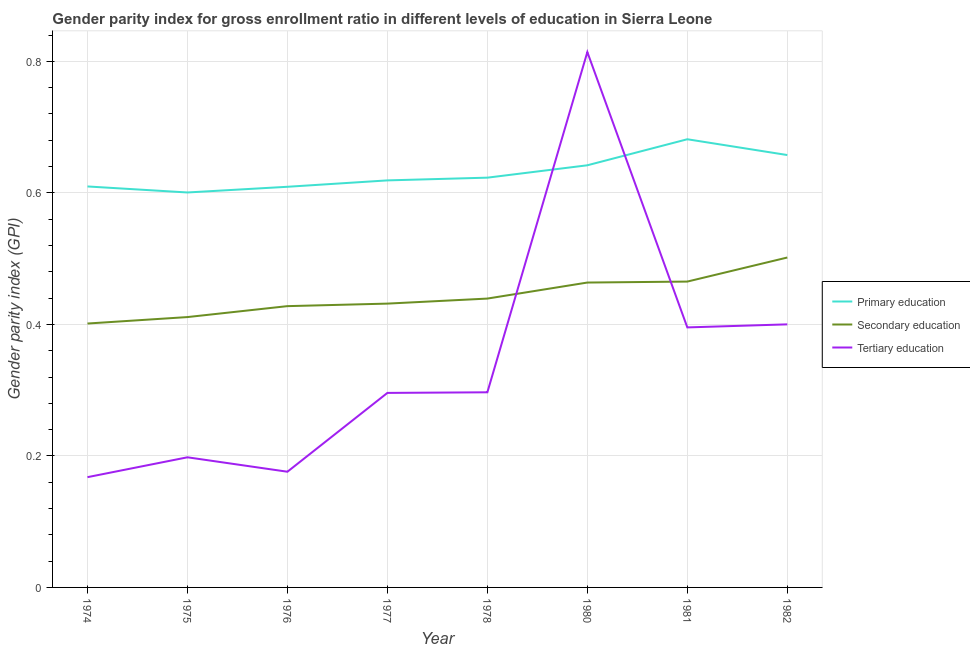Is the number of lines equal to the number of legend labels?
Make the answer very short. Yes. What is the gender parity index in primary education in 1974?
Offer a terse response. 0.61. Across all years, what is the maximum gender parity index in primary education?
Your answer should be compact. 0.68. Across all years, what is the minimum gender parity index in primary education?
Your answer should be very brief. 0.6. In which year was the gender parity index in primary education maximum?
Your answer should be very brief. 1981. In which year was the gender parity index in tertiary education minimum?
Provide a succinct answer. 1974. What is the total gender parity index in tertiary education in the graph?
Your answer should be very brief. 2.74. What is the difference between the gender parity index in primary education in 1974 and that in 1981?
Offer a terse response. -0.07. What is the difference between the gender parity index in primary education in 1977 and the gender parity index in secondary education in 1974?
Ensure brevity in your answer.  0.22. What is the average gender parity index in secondary education per year?
Make the answer very short. 0.44. In the year 1981, what is the difference between the gender parity index in tertiary education and gender parity index in primary education?
Ensure brevity in your answer.  -0.29. In how many years, is the gender parity index in tertiary education greater than 0.08?
Keep it short and to the point. 8. What is the ratio of the gender parity index in secondary education in 1977 to that in 1982?
Keep it short and to the point. 0.86. Is the gender parity index in primary education in 1980 less than that in 1982?
Offer a terse response. Yes. What is the difference between the highest and the second highest gender parity index in tertiary education?
Your answer should be compact. 0.41. What is the difference between the highest and the lowest gender parity index in primary education?
Provide a short and direct response. 0.08. Is the sum of the gender parity index in secondary education in 1974 and 1978 greater than the maximum gender parity index in tertiary education across all years?
Ensure brevity in your answer.  Yes. Does the gender parity index in tertiary education monotonically increase over the years?
Ensure brevity in your answer.  No. Is the gender parity index in tertiary education strictly less than the gender parity index in secondary education over the years?
Offer a very short reply. No. What is the difference between two consecutive major ticks on the Y-axis?
Your answer should be compact. 0.2. Does the graph contain grids?
Make the answer very short. Yes. Where does the legend appear in the graph?
Keep it short and to the point. Center right. How are the legend labels stacked?
Keep it short and to the point. Vertical. What is the title of the graph?
Provide a short and direct response. Gender parity index for gross enrollment ratio in different levels of education in Sierra Leone. Does "Textiles and clothing" appear as one of the legend labels in the graph?
Offer a very short reply. No. What is the label or title of the X-axis?
Keep it short and to the point. Year. What is the label or title of the Y-axis?
Make the answer very short. Gender parity index (GPI). What is the Gender parity index (GPI) of Primary education in 1974?
Your answer should be very brief. 0.61. What is the Gender parity index (GPI) in Secondary education in 1974?
Your answer should be compact. 0.4. What is the Gender parity index (GPI) in Tertiary education in 1974?
Your response must be concise. 0.17. What is the Gender parity index (GPI) of Primary education in 1975?
Your response must be concise. 0.6. What is the Gender parity index (GPI) of Secondary education in 1975?
Ensure brevity in your answer.  0.41. What is the Gender parity index (GPI) in Tertiary education in 1975?
Offer a terse response. 0.2. What is the Gender parity index (GPI) in Primary education in 1976?
Offer a very short reply. 0.61. What is the Gender parity index (GPI) in Secondary education in 1976?
Your response must be concise. 0.43. What is the Gender parity index (GPI) in Tertiary education in 1976?
Offer a very short reply. 0.18. What is the Gender parity index (GPI) of Primary education in 1977?
Your answer should be very brief. 0.62. What is the Gender parity index (GPI) in Secondary education in 1977?
Keep it short and to the point. 0.43. What is the Gender parity index (GPI) of Tertiary education in 1977?
Offer a terse response. 0.3. What is the Gender parity index (GPI) of Primary education in 1978?
Provide a short and direct response. 0.62. What is the Gender parity index (GPI) of Secondary education in 1978?
Keep it short and to the point. 0.44. What is the Gender parity index (GPI) of Tertiary education in 1978?
Provide a succinct answer. 0.3. What is the Gender parity index (GPI) in Primary education in 1980?
Give a very brief answer. 0.64. What is the Gender parity index (GPI) in Secondary education in 1980?
Ensure brevity in your answer.  0.46. What is the Gender parity index (GPI) of Tertiary education in 1980?
Keep it short and to the point. 0.81. What is the Gender parity index (GPI) in Primary education in 1981?
Provide a short and direct response. 0.68. What is the Gender parity index (GPI) of Secondary education in 1981?
Keep it short and to the point. 0.47. What is the Gender parity index (GPI) of Tertiary education in 1981?
Ensure brevity in your answer.  0.4. What is the Gender parity index (GPI) of Primary education in 1982?
Your answer should be very brief. 0.66. What is the Gender parity index (GPI) of Secondary education in 1982?
Make the answer very short. 0.5. What is the Gender parity index (GPI) in Tertiary education in 1982?
Your answer should be very brief. 0.4. Across all years, what is the maximum Gender parity index (GPI) in Primary education?
Your answer should be compact. 0.68. Across all years, what is the maximum Gender parity index (GPI) in Secondary education?
Provide a succinct answer. 0.5. Across all years, what is the maximum Gender parity index (GPI) of Tertiary education?
Give a very brief answer. 0.81. Across all years, what is the minimum Gender parity index (GPI) of Primary education?
Keep it short and to the point. 0.6. Across all years, what is the minimum Gender parity index (GPI) in Secondary education?
Keep it short and to the point. 0.4. Across all years, what is the minimum Gender parity index (GPI) in Tertiary education?
Provide a succinct answer. 0.17. What is the total Gender parity index (GPI) of Primary education in the graph?
Offer a very short reply. 5.04. What is the total Gender parity index (GPI) of Secondary education in the graph?
Provide a short and direct response. 3.54. What is the total Gender parity index (GPI) of Tertiary education in the graph?
Your answer should be very brief. 2.74. What is the difference between the Gender parity index (GPI) of Primary education in 1974 and that in 1975?
Your response must be concise. 0.01. What is the difference between the Gender parity index (GPI) in Secondary education in 1974 and that in 1975?
Provide a short and direct response. -0.01. What is the difference between the Gender parity index (GPI) of Tertiary education in 1974 and that in 1975?
Provide a succinct answer. -0.03. What is the difference between the Gender parity index (GPI) of Secondary education in 1974 and that in 1976?
Offer a very short reply. -0.03. What is the difference between the Gender parity index (GPI) in Tertiary education in 1974 and that in 1976?
Ensure brevity in your answer.  -0.01. What is the difference between the Gender parity index (GPI) of Primary education in 1974 and that in 1977?
Your response must be concise. -0.01. What is the difference between the Gender parity index (GPI) in Secondary education in 1974 and that in 1977?
Offer a very short reply. -0.03. What is the difference between the Gender parity index (GPI) of Tertiary education in 1974 and that in 1977?
Ensure brevity in your answer.  -0.13. What is the difference between the Gender parity index (GPI) in Primary education in 1974 and that in 1978?
Provide a short and direct response. -0.01. What is the difference between the Gender parity index (GPI) in Secondary education in 1974 and that in 1978?
Provide a succinct answer. -0.04. What is the difference between the Gender parity index (GPI) in Tertiary education in 1974 and that in 1978?
Give a very brief answer. -0.13. What is the difference between the Gender parity index (GPI) of Primary education in 1974 and that in 1980?
Your answer should be very brief. -0.03. What is the difference between the Gender parity index (GPI) of Secondary education in 1974 and that in 1980?
Give a very brief answer. -0.06. What is the difference between the Gender parity index (GPI) in Tertiary education in 1974 and that in 1980?
Ensure brevity in your answer.  -0.65. What is the difference between the Gender parity index (GPI) in Primary education in 1974 and that in 1981?
Your answer should be very brief. -0.07. What is the difference between the Gender parity index (GPI) of Secondary education in 1974 and that in 1981?
Make the answer very short. -0.06. What is the difference between the Gender parity index (GPI) of Tertiary education in 1974 and that in 1981?
Give a very brief answer. -0.23. What is the difference between the Gender parity index (GPI) in Primary education in 1974 and that in 1982?
Keep it short and to the point. -0.05. What is the difference between the Gender parity index (GPI) in Secondary education in 1974 and that in 1982?
Keep it short and to the point. -0.1. What is the difference between the Gender parity index (GPI) in Tertiary education in 1974 and that in 1982?
Your answer should be compact. -0.23. What is the difference between the Gender parity index (GPI) in Primary education in 1975 and that in 1976?
Your answer should be very brief. -0.01. What is the difference between the Gender parity index (GPI) of Secondary education in 1975 and that in 1976?
Your answer should be compact. -0.02. What is the difference between the Gender parity index (GPI) of Tertiary education in 1975 and that in 1976?
Your answer should be compact. 0.02. What is the difference between the Gender parity index (GPI) in Primary education in 1975 and that in 1977?
Provide a short and direct response. -0.02. What is the difference between the Gender parity index (GPI) in Secondary education in 1975 and that in 1977?
Offer a terse response. -0.02. What is the difference between the Gender parity index (GPI) in Tertiary education in 1975 and that in 1977?
Give a very brief answer. -0.1. What is the difference between the Gender parity index (GPI) in Primary education in 1975 and that in 1978?
Your answer should be very brief. -0.02. What is the difference between the Gender parity index (GPI) in Secondary education in 1975 and that in 1978?
Offer a very short reply. -0.03. What is the difference between the Gender parity index (GPI) in Tertiary education in 1975 and that in 1978?
Keep it short and to the point. -0.1. What is the difference between the Gender parity index (GPI) in Primary education in 1975 and that in 1980?
Your answer should be very brief. -0.04. What is the difference between the Gender parity index (GPI) of Secondary education in 1975 and that in 1980?
Offer a very short reply. -0.05. What is the difference between the Gender parity index (GPI) of Tertiary education in 1975 and that in 1980?
Provide a succinct answer. -0.62. What is the difference between the Gender parity index (GPI) in Primary education in 1975 and that in 1981?
Offer a very short reply. -0.08. What is the difference between the Gender parity index (GPI) of Secondary education in 1975 and that in 1981?
Offer a terse response. -0.05. What is the difference between the Gender parity index (GPI) of Tertiary education in 1975 and that in 1981?
Give a very brief answer. -0.2. What is the difference between the Gender parity index (GPI) of Primary education in 1975 and that in 1982?
Offer a very short reply. -0.06. What is the difference between the Gender parity index (GPI) of Secondary education in 1975 and that in 1982?
Ensure brevity in your answer.  -0.09. What is the difference between the Gender parity index (GPI) in Tertiary education in 1975 and that in 1982?
Keep it short and to the point. -0.2. What is the difference between the Gender parity index (GPI) of Primary education in 1976 and that in 1977?
Your answer should be very brief. -0.01. What is the difference between the Gender parity index (GPI) of Secondary education in 1976 and that in 1977?
Your response must be concise. -0. What is the difference between the Gender parity index (GPI) of Tertiary education in 1976 and that in 1977?
Your answer should be very brief. -0.12. What is the difference between the Gender parity index (GPI) of Primary education in 1976 and that in 1978?
Offer a terse response. -0.01. What is the difference between the Gender parity index (GPI) in Secondary education in 1976 and that in 1978?
Ensure brevity in your answer.  -0.01. What is the difference between the Gender parity index (GPI) of Tertiary education in 1976 and that in 1978?
Provide a short and direct response. -0.12. What is the difference between the Gender parity index (GPI) in Primary education in 1976 and that in 1980?
Offer a terse response. -0.03. What is the difference between the Gender parity index (GPI) of Secondary education in 1976 and that in 1980?
Offer a terse response. -0.04. What is the difference between the Gender parity index (GPI) of Tertiary education in 1976 and that in 1980?
Keep it short and to the point. -0.64. What is the difference between the Gender parity index (GPI) in Primary education in 1976 and that in 1981?
Keep it short and to the point. -0.07. What is the difference between the Gender parity index (GPI) in Secondary education in 1976 and that in 1981?
Your answer should be compact. -0.04. What is the difference between the Gender parity index (GPI) in Tertiary education in 1976 and that in 1981?
Keep it short and to the point. -0.22. What is the difference between the Gender parity index (GPI) in Primary education in 1976 and that in 1982?
Your response must be concise. -0.05. What is the difference between the Gender parity index (GPI) of Secondary education in 1976 and that in 1982?
Give a very brief answer. -0.07. What is the difference between the Gender parity index (GPI) of Tertiary education in 1976 and that in 1982?
Give a very brief answer. -0.22. What is the difference between the Gender parity index (GPI) of Primary education in 1977 and that in 1978?
Give a very brief answer. -0. What is the difference between the Gender parity index (GPI) in Secondary education in 1977 and that in 1978?
Give a very brief answer. -0.01. What is the difference between the Gender parity index (GPI) in Tertiary education in 1977 and that in 1978?
Keep it short and to the point. -0. What is the difference between the Gender parity index (GPI) in Primary education in 1977 and that in 1980?
Ensure brevity in your answer.  -0.02. What is the difference between the Gender parity index (GPI) of Secondary education in 1977 and that in 1980?
Give a very brief answer. -0.03. What is the difference between the Gender parity index (GPI) in Tertiary education in 1977 and that in 1980?
Make the answer very short. -0.52. What is the difference between the Gender parity index (GPI) in Primary education in 1977 and that in 1981?
Ensure brevity in your answer.  -0.06. What is the difference between the Gender parity index (GPI) in Secondary education in 1977 and that in 1981?
Provide a succinct answer. -0.03. What is the difference between the Gender parity index (GPI) of Tertiary education in 1977 and that in 1981?
Ensure brevity in your answer.  -0.1. What is the difference between the Gender parity index (GPI) in Primary education in 1977 and that in 1982?
Offer a terse response. -0.04. What is the difference between the Gender parity index (GPI) in Secondary education in 1977 and that in 1982?
Give a very brief answer. -0.07. What is the difference between the Gender parity index (GPI) of Tertiary education in 1977 and that in 1982?
Provide a short and direct response. -0.1. What is the difference between the Gender parity index (GPI) of Primary education in 1978 and that in 1980?
Your answer should be compact. -0.02. What is the difference between the Gender parity index (GPI) of Secondary education in 1978 and that in 1980?
Your response must be concise. -0.02. What is the difference between the Gender parity index (GPI) of Tertiary education in 1978 and that in 1980?
Keep it short and to the point. -0.52. What is the difference between the Gender parity index (GPI) of Primary education in 1978 and that in 1981?
Give a very brief answer. -0.06. What is the difference between the Gender parity index (GPI) of Secondary education in 1978 and that in 1981?
Give a very brief answer. -0.03. What is the difference between the Gender parity index (GPI) in Tertiary education in 1978 and that in 1981?
Provide a short and direct response. -0.1. What is the difference between the Gender parity index (GPI) of Primary education in 1978 and that in 1982?
Keep it short and to the point. -0.03. What is the difference between the Gender parity index (GPI) in Secondary education in 1978 and that in 1982?
Ensure brevity in your answer.  -0.06. What is the difference between the Gender parity index (GPI) of Tertiary education in 1978 and that in 1982?
Ensure brevity in your answer.  -0.1. What is the difference between the Gender parity index (GPI) in Primary education in 1980 and that in 1981?
Provide a short and direct response. -0.04. What is the difference between the Gender parity index (GPI) of Secondary education in 1980 and that in 1981?
Provide a short and direct response. -0. What is the difference between the Gender parity index (GPI) of Tertiary education in 1980 and that in 1981?
Keep it short and to the point. 0.42. What is the difference between the Gender parity index (GPI) in Primary education in 1980 and that in 1982?
Give a very brief answer. -0.02. What is the difference between the Gender parity index (GPI) in Secondary education in 1980 and that in 1982?
Offer a terse response. -0.04. What is the difference between the Gender parity index (GPI) in Tertiary education in 1980 and that in 1982?
Give a very brief answer. 0.41. What is the difference between the Gender parity index (GPI) of Primary education in 1981 and that in 1982?
Keep it short and to the point. 0.02. What is the difference between the Gender parity index (GPI) of Secondary education in 1981 and that in 1982?
Keep it short and to the point. -0.04. What is the difference between the Gender parity index (GPI) in Tertiary education in 1981 and that in 1982?
Your response must be concise. -0. What is the difference between the Gender parity index (GPI) of Primary education in 1974 and the Gender parity index (GPI) of Secondary education in 1975?
Your answer should be compact. 0.2. What is the difference between the Gender parity index (GPI) of Primary education in 1974 and the Gender parity index (GPI) of Tertiary education in 1975?
Ensure brevity in your answer.  0.41. What is the difference between the Gender parity index (GPI) of Secondary education in 1974 and the Gender parity index (GPI) of Tertiary education in 1975?
Offer a terse response. 0.2. What is the difference between the Gender parity index (GPI) in Primary education in 1974 and the Gender parity index (GPI) in Secondary education in 1976?
Keep it short and to the point. 0.18. What is the difference between the Gender parity index (GPI) of Primary education in 1974 and the Gender parity index (GPI) of Tertiary education in 1976?
Your response must be concise. 0.43. What is the difference between the Gender parity index (GPI) of Secondary education in 1974 and the Gender parity index (GPI) of Tertiary education in 1976?
Ensure brevity in your answer.  0.23. What is the difference between the Gender parity index (GPI) in Primary education in 1974 and the Gender parity index (GPI) in Secondary education in 1977?
Offer a very short reply. 0.18. What is the difference between the Gender parity index (GPI) in Primary education in 1974 and the Gender parity index (GPI) in Tertiary education in 1977?
Keep it short and to the point. 0.31. What is the difference between the Gender parity index (GPI) in Secondary education in 1974 and the Gender parity index (GPI) in Tertiary education in 1977?
Ensure brevity in your answer.  0.11. What is the difference between the Gender parity index (GPI) in Primary education in 1974 and the Gender parity index (GPI) in Secondary education in 1978?
Your answer should be compact. 0.17. What is the difference between the Gender parity index (GPI) of Primary education in 1974 and the Gender parity index (GPI) of Tertiary education in 1978?
Give a very brief answer. 0.31. What is the difference between the Gender parity index (GPI) of Secondary education in 1974 and the Gender parity index (GPI) of Tertiary education in 1978?
Give a very brief answer. 0.1. What is the difference between the Gender parity index (GPI) of Primary education in 1974 and the Gender parity index (GPI) of Secondary education in 1980?
Offer a very short reply. 0.15. What is the difference between the Gender parity index (GPI) of Primary education in 1974 and the Gender parity index (GPI) of Tertiary education in 1980?
Offer a very short reply. -0.2. What is the difference between the Gender parity index (GPI) in Secondary education in 1974 and the Gender parity index (GPI) in Tertiary education in 1980?
Provide a short and direct response. -0.41. What is the difference between the Gender parity index (GPI) in Primary education in 1974 and the Gender parity index (GPI) in Secondary education in 1981?
Your answer should be very brief. 0.14. What is the difference between the Gender parity index (GPI) of Primary education in 1974 and the Gender parity index (GPI) of Tertiary education in 1981?
Offer a terse response. 0.21. What is the difference between the Gender parity index (GPI) of Secondary education in 1974 and the Gender parity index (GPI) of Tertiary education in 1981?
Your answer should be compact. 0.01. What is the difference between the Gender parity index (GPI) in Primary education in 1974 and the Gender parity index (GPI) in Secondary education in 1982?
Provide a short and direct response. 0.11. What is the difference between the Gender parity index (GPI) of Primary education in 1974 and the Gender parity index (GPI) of Tertiary education in 1982?
Keep it short and to the point. 0.21. What is the difference between the Gender parity index (GPI) in Secondary education in 1974 and the Gender parity index (GPI) in Tertiary education in 1982?
Make the answer very short. 0. What is the difference between the Gender parity index (GPI) in Primary education in 1975 and the Gender parity index (GPI) in Secondary education in 1976?
Provide a succinct answer. 0.17. What is the difference between the Gender parity index (GPI) in Primary education in 1975 and the Gender parity index (GPI) in Tertiary education in 1976?
Provide a short and direct response. 0.42. What is the difference between the Gender parity index (GPI) in Secondary education in 1975 and the Gender parity index (GPI) in Tertiary education in 1976?
Your answer should be compact. 0.24. What is the difference between the Gender parity index (GPI) in Primary education in 1975 and the Gender parity index (GPI) in Secondary education in 1977?
Your response must be concise. 0.17. What is the difference between the Gender parity index (GPI) in Primary education in 1975 and the Gender parity index (GPI) in Tertiary education in 1977?
Keep it short and to the point. 0.3. What is the difference between the Gender parity index (GPI) of Secondary education in 1975 and the Gender parity index (GPI) of Tertiary education in 1977?
Provide a succinct answer. 0.12. What is the difference between the Gender parity index (GPI) in Primary education in 1975 and the Gender parity index (GPI) in Secondary education in 1978?
Offer a terse response. 0.16. What is the difference between the Gender parity index (GPI) of Primary education in 1975 and the Gender parity index (GPI) of Tertiary education in 1978?
Provide a short and direct response. 0.3. What is the difference between the Gender parity index (GPI) of Secondary education in 1975 and the Gender parity index (GPI) of Tertiary education in 1978?
Keep it short and to the point. 0.11. What is the difference between the Gender parity index (GPI) of Primary education in 1975 and the Gender parity index (GPI) of Secondary education in 1980?
Provide a succinct answer. 0.14. What is the difference between the Gender parity index (GPI) of Primary education in 1975 and the Gender parity index (GPI) of Tertiary education in 1980?
Provide a short and direct response. -0.21. What is the difference between the Gender parity index (GPI) in Secondary education in 1975 and the Gender parity index (GPI) in Tertiary education in 1980?
Keep it short and to the point. -0.4. What is the difference between the Gender parity index (GPI) in Primary education in 1975 and the Gender parity index (GPI) in Secondary education in 1981?
Provide a succinct answer. 0.14. What is the difference between the Gender parity index (GPI) in Primary education in 1975 and the Gender parity index (GPI) in Tertiary education in 1981?
Offer a very short reply. 0.21. What is the difference between the Gender parity index (GPI) in Secondary education in 1975 and the Gender parity index (GPI) in Tertiary education in 1981?
Keep it short and to the point. 0.02. What is the difference between the Gender parity index (GPI) in Primary education in 1975 and the Gender parity index (GPI) in Secondary education in 1982?
Offer a terse response. 0.1. What is the difference between the Gender parity index (GPI) in Primary education in 1975 and the Gender parity index (GPI) in Tertiary education in 1982?
Give a very brief answer. 0.2. What is the difference between the Gender parity index (GPI) of Secondary education in 1975 and the Gender parity index (GPI) of Tertiary education in 1982?
Your answer should be very brief. 0.01. What is the difference between the Gender parity index (GPI) in Primary education in 1976 and the Gender parity index (GPI) in Secondary education in 1977?
Provide a succinct answer. 0.18. What is the difference between the Gender parity index (GPI) in Primary education in 1976 and the Gender parity index (GPI) in Tertiary education in 1977?
Ensure brevity in your answer.  0.31. What is the difference between the Gender parity index (GPI) in Secondary education in 1976 and the Gender parity index (GPI) in Tertiary education in 1977?
Provide a succinct answer. 0.13. What is the difference between the Gender parity index (GPI) in Primary education in 1976 and the Gender parity index (GPI) in Secondary education in 1978?
Make the answer very short. 0.17. What is the difference between the Gender parity index (GPI) of Primary education in 1976 and the Gender parity index (GPI) of Tertiary education in 1978?
Make the answer very short. 0.31. What is the difference between the Gender parity index (GPI) of Secondary education in 1976 and the Gender parity index (GPI) of Tertiary education in 1978?
Offer a terse response. 0.13. What is the difference between the Gender parity index (GPI) of Primary education in 1976 and the Gender parity index (GPI) of Secondary education in 1980?
Keep it short and to the point. 0.15. What is the difference between the Gender parity index (GPI) in Primary education in 1976 and the Gender parity index (GPI) in Tertiary education in 1980?
Offer a very short reply. -0.2. What is the difference between the Gender parity index (GPI) of Secondary education in 1976 and the Gender parity index (GPI) of Tertiary education in 1980?
Your response must be concise. -0.39. What is the difference between the Gender parity index (GPI) of Primary education in 1976 and the Gender parity index (GPI) of Secondary education in 1981?
Offer a terse response. 0.14. What is the difference between the Gender parity index (GPI) of Primary education in 1976 and the Gender parity index (GPI) of Tertiary education in 1981?
Your answer should be very brief. 0.21. What is the difference between the Gender parity index (GPI) in Secondary education in 1976 and the Gender parity index (GPI) in Tertiary education in 1981?
Give a very brief answer. 0.03. What is the difference between the Gender parity index (GPI) of Primary education in 1976 and the Gender parity index (GPI) of Secondary education in 1982?
Provide a succinct answer. 0.11. What is the difference between the Gender parity index (GPI) in Primary education in 1976 and the Gender parity index (GPI) in Tertiary education in 1982?
Offer a terse response. 0.21. What is the difference between the Gender parity index (GPI) in Secondary education in 1976 and the Gender parity index (GPI) in Tertiary education in 1982?
Your answer should be compact. 0.03. What is the difference between the Gender parity index (GPI) of Primary education in 1977 and the Gender parity index (GPI) of Secondary education in 1978?
Provide a short and direct response. 0.18. What is the difference between the Gender parity index (GPI) in Primary education in 1977 and the Gender parity index (GPI) in Tertiary education in 1978?
Your answer should be compact. 0.32. What is the difference between the Gender parity index (GPI) in Secondary education in 1977 and the Gender parity index (GPI) in Tertiary education in 1978?
Make the answer very short. 0.13. What is the difference between the Gender parity index (GPI) in Primary education in 1977 and the Gender parity index (GPI) in Secondary education in 1980?
Your answer should be compact. 0.16. What is the difference between the Gender parity index (GPI) in Primary education in 1977 and the Gender parity index (GPI) in Tertiary education in 1980?
Your answer should be very brief. -0.2. What is the difference between the Gender parity index (GPI) of Secondary education in 1977 and the Gender parity index (GPI) of Tertiary education in 1980?
Provide a succinct answer. -0.38. What is the difference between the Gender parity index (GPI) in Primary education in 1977 and the Gender parity index (GPI) in Secondary education in 1981?
Offer a terse response. 0.15. What is the difference between the Gender parity index (GPI) of Primary education in 1977 and the Gender parity index (GPI) of Tertiary education in 1981?
Make the answer very short. 0.22. What is the difference between the Gender parity index (GPI) of Secondary education in 1977 and the Gender parity index (GPI) of Tertiary education in 1981?
Your answer should be very brief. 0.04. What is the difference between the Gender parity index (GPI) in Primary education in 1977 and the Gender parity index (GPI) in Secondary education in 1982?
Your response must be concise. 0.12. What is the difference between the Gender parity index (GPI) in Primary education in 1977 and the Gender parity index (GPI) in Tertiary education in 1982?
Offer a very short reply. 0.22. What is the difference between the Gender parity index (GPI) in Secondary education in 1977 and the Gender parity index (GPI) in Tertiary education in 1982?
Provide a short and direct response. 0.03. What is the difference between the Gender parity index (GPI) of Primary education in 1978 and the Gender parity index (GPI) of Secondary education in 1980?
Your answer should be very brief. 0.16. What is the difference between the Gender parity index (GPI) of Primary education in 1978 and the Gender parity index (GPI) of Tertiary education in 1980?
Ensure brevity in your answer.  -0.19. What is the difference between the Gender parity index (GPI) in Secondary education in 1978 and the Gender parity index (GPI) in Tertiary education in 1980?
Make the answer very short. -0.37. What is the difference between the Gender parity index (GPI) in Primary education in 1978 and the Gender parity index (GPI) in Secondary education in 1981?
Provide a short and direct response. 0.16. What is the difference between the Gender parity index (GPI) of Primary education in 1978 and the Gender parity index (GPI) of Tertiary education in 1981?
Provide a succinct answer. 0.23. What is the difference between the Gender parity index (GPI) in Secondary education in 1978 and the Gender parity index (GPI) in Tertiary education in 1981?
Ensure brevity in your answer.  0.04. What is the difference between the Gender parity index (GPI) in Primary education in 1978 and the Gender parity index (GPI) in Secondary education in 1982?
Your answer should be very brief. 0.12. What is the difference between the Gender parity index (GPI) in Primary education in 1978 and the Gender parity index (GPI) in Tertiary education in 1982?
Give a very brief answer. 0.22. What is the difference between the Gender parity index (GPI) in Secondary education in 1978 and the Gender parity index (GPI) in Tertiary education in 1982?
Your answer should be compact. 0.04. What is the difference between the Gender parity index (GPI) in Primary education in 1980 and the Gender parity index (GPI) in Secondary education in 1981?
Make the answer very short. 0.18. What is the difference between the Gender parity index (GPI) of Primary education in 1980 and the Gender parity index (GPI) of Tertiary education in 1981?
Ensure brevity in your answer.  0.25. What is the difference between the Gender parity index (GPI) in Secondary education in 1980 and the Gender parity index (GPI) in Tertiary education in 1981?
Ensure brevity in your answer.  0.07. What is the difference between the Gender parity index (GPI) in Primary education in 1980 and the Gender parity index (GPI) in Secondary education in 1982?
Your response must be concise. 0.14. What is the difference between the Gender parity index (GPI) of Primary education in 1980 and the Gender parity index (GPI) of Tertiary education in 1982?
Ensure brevity in your answer.  0.24. What is the difference between the Gender parity index (GPI) in Secondary education in 1980 and the Gender parity index (GPI) in Tertiary education in 1982?
Your response must be concise. 0.06. What is the difference between the Gender parity index (GPI) in Primary education in 1981 and the Gender parity index (GPI) in Secondary education in 1982?
Offer a terse response. 0.18. What is the difference between the Gender parity index (GPI) in Primary education in 1981 and the Gender parity index (GPI) in Tertiary education in 1982?
Provide a succinct answer. 0.28. What is the difference between the Gender parity index (GPI) in Secondary education in 1981 and the Gender parity index (GPI) in Tertiary education in 1982?
Make the answer very short. 0.07. What is the average Gender parity index (GPI) in Primary education per year?
Provide a succinct answer. 0.63. What is the average Gender parity index (GPI) in Secondary education per year?
Offer a terse response. 0.44. What is the average Gender parity index (GPI) in Tertiary education per year?
Your response must be concise. 0.34. In the year 1974, what is the difference between the Gender parity index (GPI) of Primary education and Gender parity index (GPI) of Secondary education?
Offer a terse response. 0.21. In the year 1974, what is the difference between the Gender parity index (GPI) in Primary education and Gender parity index (GPI) in Tertiary education?
Give a very brief answer. 0.44. In the year 1974, what is the difference between the Gender parity index (GPI) of Secondary education and Gender parity index (GPI) of Tertiary education?
Give a very brief answer. 0.23. In the year 1975, what is the difference between the Gender parity index (GPI) in Primary education and Gender parity index (GPI) in Secondary education?
Your response must be concise. 0.19. In the year 1975, what is the difference between the Gender parity index (GPI) of Primary education and Gender parity index (GPI) of Tertiary education?
Make the answer very short. 0.4. In the year 1975, what is the difference between the Gender parity index (GPI) in Secondary education and Gender parity index (GPI) in Tertiary education?
Your answer should be very brief. 0.21. In the year 1976, what is the difference between the Gender parity index (GPI) in Primary education and Gender parity index (GPI) in Secondary education?
Ensure brevity in your answer.  0.18. In the year 1976, what is the difference between the Gender parity index (GPI) of Primary education and Gender parity index (GPI) of Tertiary education?
Make the answer very short. 0.43. In the year 1976, what is the difference between the Gender parity index (GPI) of Secondary education and Gender parity index (GPI) of Tertiary education?
Your answer should be compact. 0.25. In the year 1977, what is the difference between the Gender parity index (GPI) of Primary education and Gender parity index (GPI) of Secondary education?
Your response must be concise. 0.19. In the year 1977, what is the difference between the Gender parity index (GPI) in Primary education and Gender parity index (GPI) in Tertiary education?
Keep it short and to the point. 0.32. In the year 1977, what is the difference between the Gender parity index (GPI) of Secondary education and Gender parity index (GPI) of Tertiary education?
Offer a terse response. 0.14. In the year 1978, what is the difference between the Gender parity index (GPI) in Primary education and Gender parity index (GPI) in Secondary education?
Your answer should be compact. 0.18. In the year 1978, what is the difference between the Gender parity index (GPI) in Primary education and Gender parity index (GPI) in Tertiary education?
Provide a short and direct response. 0.33. In the year 1978, what is the difference between the Gender parity index (GPI) of Secondary education and Gender parity index (GPI) of Tertiary education?
Offer a terse response. 0.14. In the year 1980, what is the difference between the Gender parity index (GPI) in Primary education and Gender parity index (GPI) in Secondary education?
Provide a short and direct response. 0.18. In the year 1980, what is the difference between the Gender parity index (GPI) of Primary education and Gender parity index (GPI) of Tertiary education?
Ensure brevity in your answer.  -0.17. In the year 1980, what is the difference between the Gender parity index (GPI) in Secondary education and Gender parity index (GPI) in Tertiary education?
Provide a succinct answer. -0.35. In the year 1981, what is the difference between the Gender parity index (GPI) in Primary education and Gender parity index (GPI) in Secondary education?
Your answer should be very brief. 0.22. In the year 1981, what is the difference between the Gender parity index (GPI) of Primary education and Gender parity index (GPI) of Tertiary education?
Your response must be concise. 0.29. In the year 1981, what is the difference between the Gender parity index (GPI) in Secondary education and Gender parity index (GPI) in Tertiary education?
Ensure brevity in your answer.  0.07. In the year 1982, what is the difference between the Gender parity index (GPI) in Primary education and Gender parity index (GPI) in Secondary education?
Offer a very short reply. 0.16. In the year 1982, what is the difference between the Gender parity index (GPI) of Primary education and Gender parity index (GPI) of Tertiary education?
Keep it short and to the point. 0.26. In the year 1982, what is the difference between the Gender parity index (GPI) in Secondary education and Gender parity index (GPI) in Tertiary education?
Provide a short and direct response. 0.1. What is the ratio of the Gender parity index (GPI) in Primary education in 1974 to that in 1975?
Make the answer very short. 1.02. What is the ratio of the Gender parity index (GPI) of Secondary education in 1974 to that in 1975?
Ensure brevity in your answer.  0.98. What is the ratio of the Gender parity index (GPI) in Tertiary education in 1974 to that in 1975?
Your answer should be compact. 0.85. What is the ratio of the Gender parity index (GPI) of Secondary education in 1974 to that in 1976?
Your answer should be very brief. 0.94. What is the ratio of the Gender parity index (GPI) in Tertiary education in 1974 to that in 1976?
Give a very brief answer. 0.95. What is the ratio of the Gender parity index (GPI) in Primary education in 1974 to that in 1977?
Keep it short and to the point. 0.99. What is the ratio of the Gender parity index (GPI) of Secondary education in 1974 to that in 1977?
Provide a succinct answer. 0.93. What is the ratio of the Gender parity index (GPI) in Tertiary education in 1974 to that in 1977?
Ensure brevity in your answer.  0.57. What is the ratio of the Gender parity index (GPI) in Primary education in 1974 to that in 1978?
Offer a very short reply. 0.98. What is the ratio of the Gender parity index (GPI) of Secondary education in 1974 to that in 1978?
Offer a very short reply. 0.91. What is the ratio of the Gender parity index (GPI) of Tertiary education in 1974 to that in 1978?
Your answer should be very brief. 0.57. What is the ratio of the Gender parity index (GPI) of Primary education in 1974 to that in 1980?
Provide a short and direct response. 0.95. What is the ratio of the Gender parity index (GPI) of Secondary education in 1974 to that in 1980?
Your answer should be compact. 0.87. What is the ratio of the Gender parity index (GPI) of Tertiary education in 1974 to that in 1980?
Give a very brief answer. 0.21. What is the ratio of the Gender parity index (GPI) in Primary education in 1974 to that in 1981?
Ensure brevity in your answer.  0.89. What is the ratio of the Gender parity index (GPI) of Secondary education in 1974 to that in 1981?
Give a very brief answer. 0.86. What is the ratio of the Gender parity index (GPI) in Tertiary education in 1974 to that in 1981?
Offer a very short reply. 0.42. What is the ratio of the Gender parity index (GPI) of Primary education in 1974 to that in 1982?
Provide a short and direct response. 0.93. What is the ratio of the Gender parity index (GPI) in Secondary education in 1974 to that in 1982?
Your response must be concise. 0.8. What is the ratio of the Gender parity index (GPI) of Tertiary education in 1974 to that in 1982?
Provide a short and direct response. 0.42. What is the ratio of the Gender parity index (GPI) in Primary education in 1975 to that in 1976?
Offer a very short reply. 0.99. What is the ratio of the Gender parity index (GPI) of Secondary education in 1975 to that in 1976?
Your response must be concise. 0.96. What is the ratio of the Gender parity index (GPI) of Tertiary education in 1975 to that in 1976?
Keep it short and to the point. 1.12. What is the ratio of the Gender parity index (GPI) in Primary education in 1975 to that in 1977?
Your answer should be compact. 0.97. What is the ratio of the Gender parity index (GPI) of Secondary education in 1975 to that in 1977?
Your response must be concise. 0.95. What is the ratio of the Gender parity index (GPI) in Tertiary education in 1975 to that in 1977?
Provide a short and direct response. 0.67. What is the ratio of the Gender parity index (GPI) of Primary education in 1975 to that in 1978?
Give a very brief answer. 0.96. What is the ratio of the Gender parity index (GPI) in Secondary education in 1975 to that in 1978?
Offer a terse response. 0.94. What is the ratio of the Gender parity index (GPI) in Tertiary education in 1975 to that in 1978?
Offer a very short reply. 0.67. What is the ratio of the Gender parity index (GPI) of Primary education in 1975 to that in 1980?
Give a very brief answer. 0.94. What is the ratio of the Gender parity index (GPI) of Secondary education in 1975 to that in 1980?
Your response must be concise. 0.89. What is the ratio of the Gender parity index (GPI) in Tertiary education in 1975 to that in 1980?
Provide a succinct answer. 0.24. What is the ratio of the Gender parity index (GPI) in Primary education in 1975 to that in 1981?
Provide a succinct answer. 0.88. What is the ratio of the Gender parity index (GPI) of Secondary education in 1975 to that in 1981?
Provide a short and direct response. 0.88. What is the ratio of the Gender parity index (GPI) in Tertiary education in 1975 to that in 1981?
Your answer should be compact. 0.5. What is the ratio of the Gender parity index (GPI) of Primary education in 1975 to that in 1982?
Your answer should be compact. 0.91. What is the ratio of the Gender parity index (GPI) of Secondary education in 1975 to that in 1982?
Provide a short and direct response. 0.82. What is the ratio of the Gender parity index (GPI) in Tertiary education in 1975 to that in 1982?
Keep it short and to the point. 0.49. What is the ratio of the Gender parity index (GPI) of Primary education in 1976 to that in 1977?
Your answer should be compact. 0.98. What is the ratio of the Gender parity index (GPI) in Tertiary education in 1976 to that in 1977?
Provide a succinct answer. 0.59. What is the ratio of the Gender parity index (GPI) of Primary education in 1976 to that in 1978?
Your answer should be very brief. 0.98. What is the ratio of the Gender parity index (GPI) of Secondary education in 1976 to that in 1978?
Provide a succinct answer. 0.97. What is the ratio of the Gender parity index (GPI) of Tertiary education in 1976 to that in 1978?
Offer a terse response. 0.59. What is the ratio of the Gender parity index (GPI) in Primary education in 1976 to that in 1980?
Give a very brief answer. 0.95. What is the ratio of the Gender parity index (GPI) in Secondary education in 1976 to that in 1980?
Provide a succinct answer. 0.92. What is the ratio of the Gender parity index (GPI) in Tertiary education in 1976 to that in 1980?
Ensure brevity in your answer.  0.22. What is the ratio of the Gender parity index (GPI) in Primary education in 1976 to that in 1981?
Offer a terse response. 0.89. What is the ratio of the Gender parity index (GPI) of Secondary education in 1976 to that in 1981?
Give a very brief answer. 0.92. What is the ratio of the Gender parity index (GPI) of Tertiary education in 1976 to that in 1981?
Ensure brevity in your answer.  0.45. What is the ratio of the Gender parity index (GPI) in Primary education in 1976 to that in 1982?
Keep it short and to the point. 0.93. What is the ratio of the Gender parity index (GPI) in Secondary education in 1976 to that in 1982?
Your response must be concise. 0.85. What is the ratio of the Gender parity index (GPI) in Tertiary education in 1976 to that in 1982?
Give a very brief answer. 0.44. What is the ratio of the Gender parity index (GPI) in Primary education in 1977 to that in 1978?
Your response must be concise. 0.99. What is the ratio of the Gender parity index (GPI) in Secondary education in 1977 to that in 1978?
Make the answer very short. 0.98. What is the ratio of the Gender parity index (GPI) of Tertiary education in 1977 to that in 1978?
Provide a short and direct response. 1. What is the ratio of the Gender parity index (GPI) of Primary education in 1977 to that in 1980?
Give a very brief answer. 0.96. What is the ratio of the Gender parity index (GPI) of Secondary education in 1977 to that in 1980?
Ensure brevity in your answer.  0.93. What is the ratio of the Gender parity index (GPI) in Tertiary education in 1977 to that in 1980?
Offer a terse response. 0.36. What is the ratio of the Gender parity index (GPI) of Primary education in 1977 to that in 1981?
Give a very brief answer. 0.91. What is the ratio of the Gender parity index (GPI) in Secondary education in 1977 to that in 1981?
Your response must be concise. 0.93. What is the ratio of the Gender parity index (GPI) of Tertiary education in 1977 to that in 1981?
Offer a very short reply. 0.75. What is the ratio of the Gender parity index (GPI) in Primary education in 1977 to that in 1982?
Make the answer very short. 0.94. What is the ratio of the Gender parity index (GPI) of Secondary education in 1977 to that in 1982?
Keep it short and to the point. 0.86. What is the ratio of the Gender parity index (GPI) in Tertiary education in 1977 to that in 1982?
Your answer should be compact. 0.74. What is the ratio of the Gender parity index (GPI) in Primary education in 1978 to that in 1980?
Your response must be concise. 0.97. What is the ratio of the Gender parity index (GPI) in Tertiary education in 1978 to that in 1980?
Your response must be concise. 0.36. What is the ratio of the Gender parity index (GPI) in Primary education in 1978 to that in 1981?
Offer a terse response. 0.91. What is the ratio of the Gender parity index (GPI) of Secondary education in 1978 to that in 1981?
Provide a succinct answer. 0.94. What is the ratio of the Gender parity index (GPI) of Tertiary education in 1978 to that in 1981?
Ensure brevity in your answer.  0.75. What is the ratio of the Gender parity index (GPI) of Primary education in 1978 to that in 1982?
Provide a short and direct response. 0.95. What is the ratio of the Gender parity index (GPI) in Secondary education in 1978 to that in 1982?
Keep it short and to the point. 0.88. What is the ratio of the Gender parity index (GPI) in Tertiary education in 1978 to that in 1982?
Your response must be concise. 0.74. What is the ratio of the Gender parity index (GPI) of Primary education in 1980 to that in 1981?
Offer a terse response. 0.94. What is the ratio of the Gender parity index (GPI) in Tertiary education in 1980 to that in 1981?
Offer a terse response. 2.06. What is the ratio of the Gender parity index (GPI) in Primary education in 1980 to that in 1982?
Ensure brevity in your answer.  0.98. What is the ratio of the Gender parity index (GPI) in Secondary education in 1980 to that in 1982?
Make the answer very short. 0.92. What is the ratio of the Gender parity index (GPI) of Tertiary education in 1980 to that in 1982?
Your answer should be very brief. 2.04. What is the ratio of the Gender parity index (GPI) of Primary education in 1981 to that in 1982?
Make the answer very short. 1.04. What is the ratio of the Gender parity index (GPI) in Secondary education in 1981 to that in 1982?
Your answer should be very brief. 0.93. What is the difference between the highest and the second highest Gender parity index (GPI) of Primary education?
Offer a very short reply. 0.02. What is the difference between the highest and the second highest Gender parity index (GPI) of Secondary education?
Offer a terse response. 0.04. What is the difference between the highest and the second highest Gender parity index (GPI) in Tertiary education?
Offer a terse response. 0.41. What is the difference between the highest and the lowest Gender parity index (GPI) in Primary education?
Offer a terse response. 0.08. What is the difference between the highest and the lowest Gender parity index (GPI) in Secondary education?
Provide a succinct answer. 0.1. What is the difference between the highest and the lowest Gender parity index (GPI) in Tertiary education?
Your answer should be very brief. 0.65. 